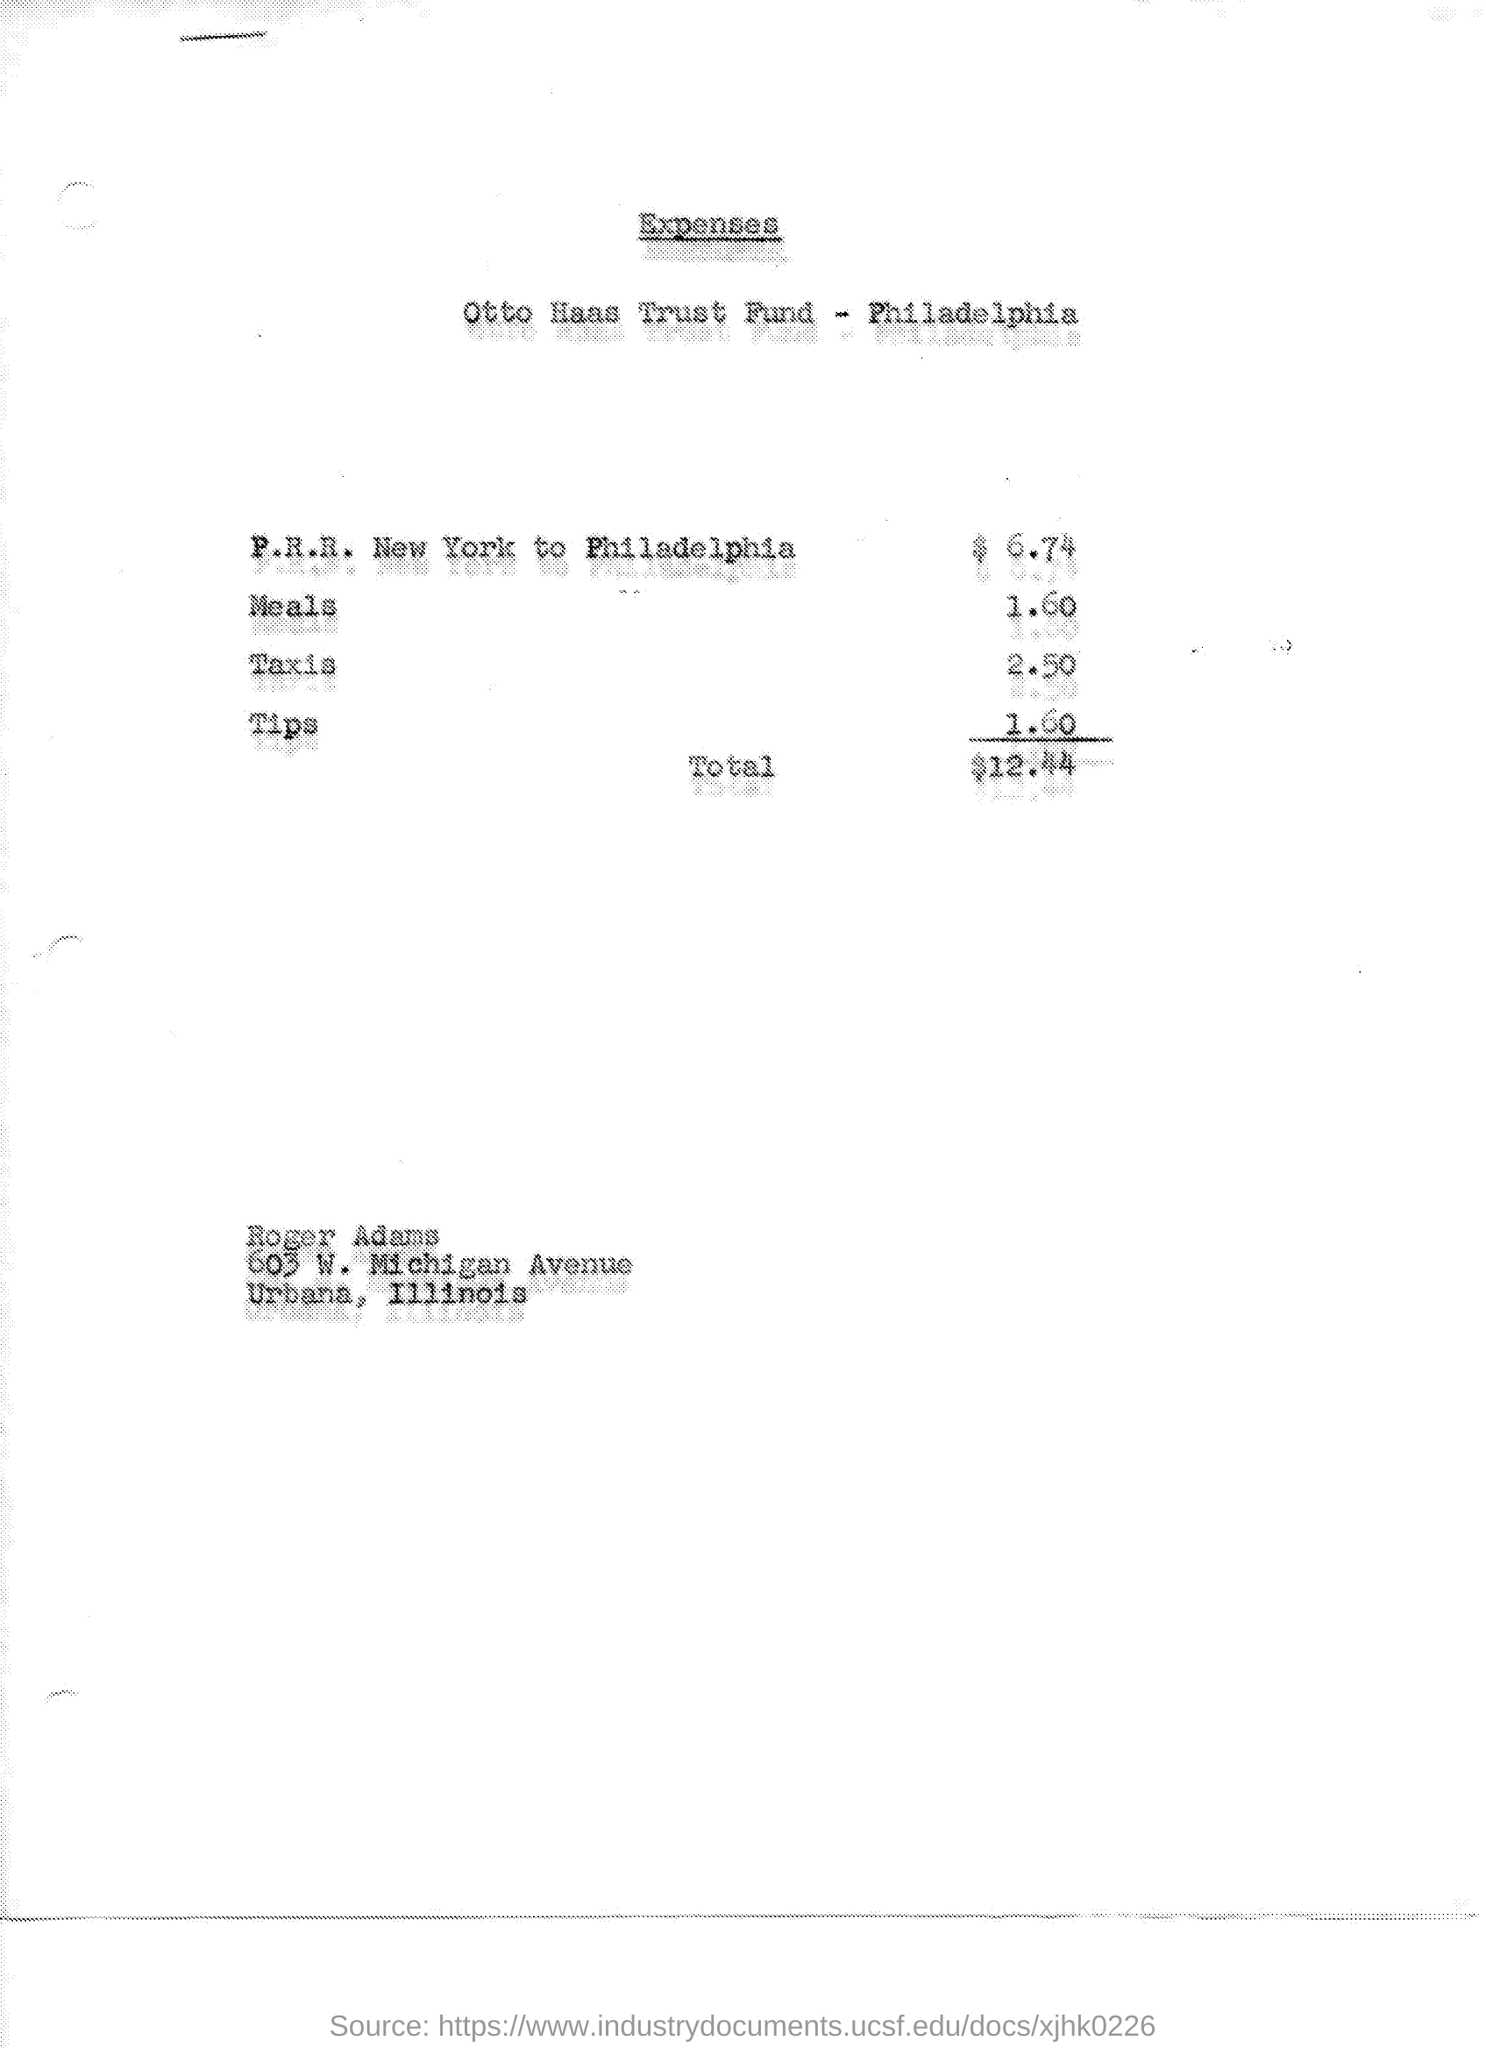Point out several critical features in this image. The cost for a trip from New York to Philadelphia by P.R.R. is $6.74. The amount spent on taxis was $2.50. I know where he spent 1.60 dollars," said the man, referring to tips. 